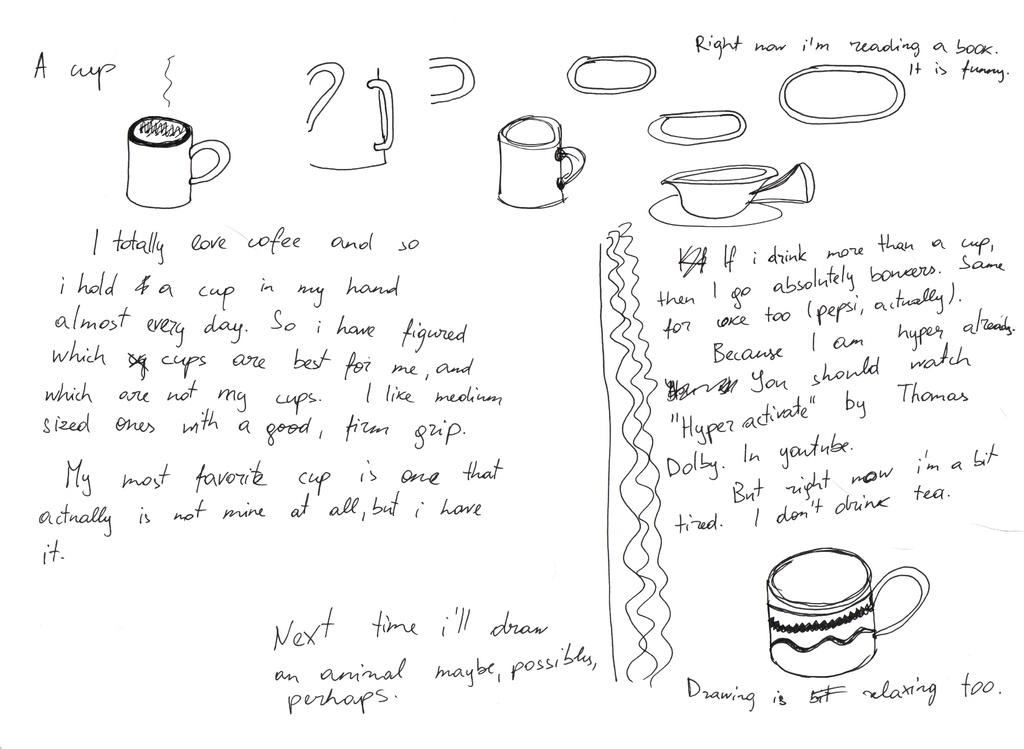What type of art is featured in the image? There is pencil art in the image. What is the subject of the pencil art? The pencil art depicts coffee mugs. Is there any text associated with the pencil art? Yes, there is text below the pencil art. What type of grain is visible in the image? There is no grain present in the image. Can you see the artist's wrist while they are drawing the pencil art in the image? The image does not show the artist's wrist or the process of creating the pencil art. 